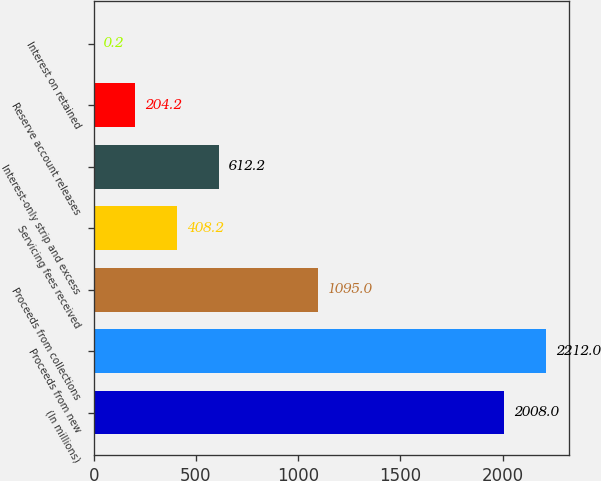<chart> <loc_0><loc_0><loc_500><loc_500><bar_chart><fcel>(In millions)<fcel>Proceeds from new<fcel>Proceeds from collections<fcel>Servicing fees received<fcel>Interest-only strip and excess<fcel>Reserve account releases<fcel>Interest on retained<nl><fcel>2008<fcel>2212<fcel>1095<fcel>408.2<fcel>612.2<fcel>204.2<fcel>0.2<nl></chart> 